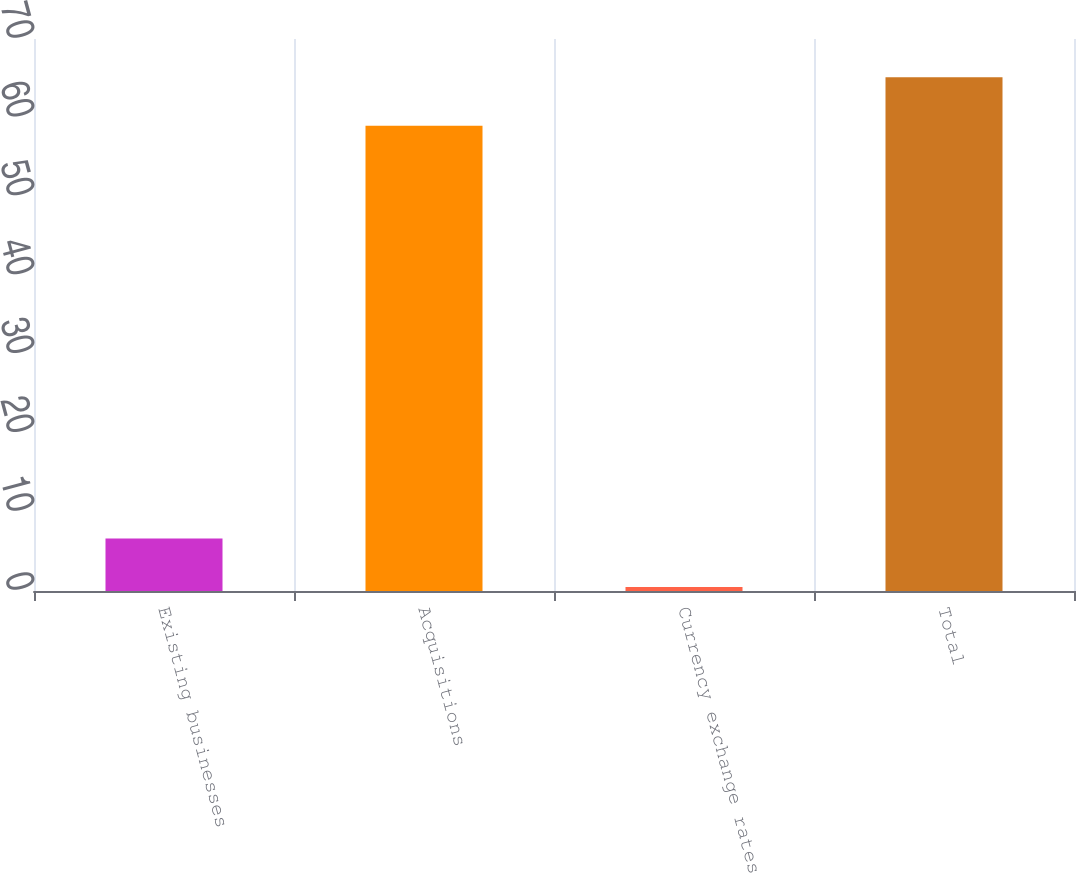Convert chart to OTSL. <chart><loc_0><loc_0><loc_500><loc_500><bar_chart><fcel>Existing businesses<fcel>Acquisitions<fcel>Currency exchange rates<fcel>Total<nl><fcel>6.65<fcel>59<fcel>0.5<fcel>65.15<nl></chart> 